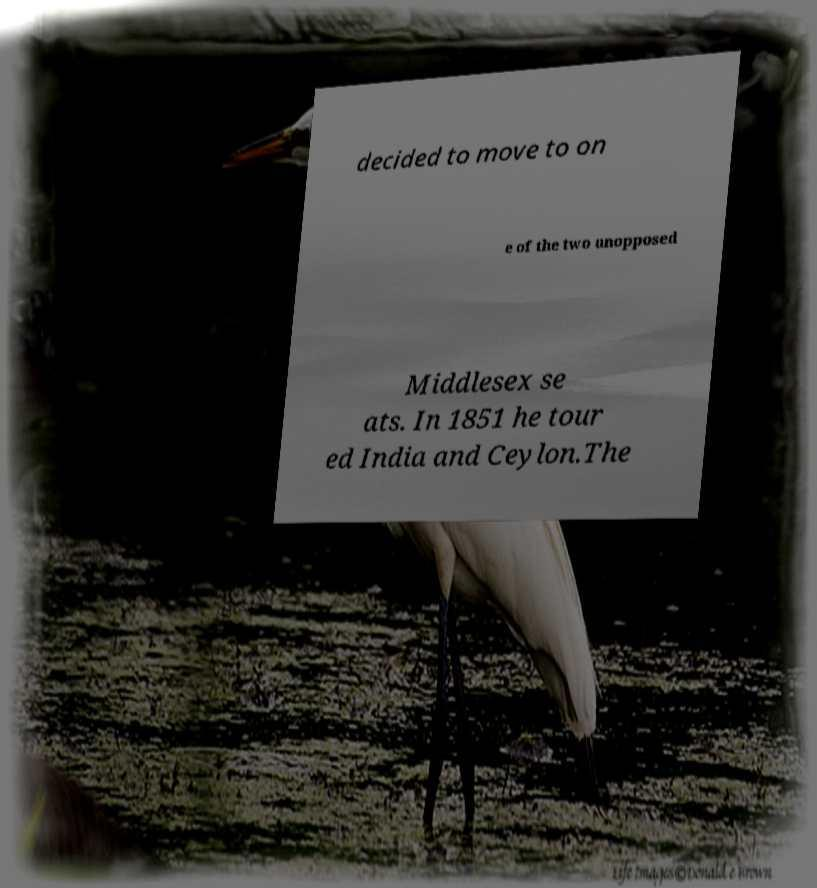What messages or text are displayed in this image? I need them in a readable, typed format. decided to move to on e of the two unopposed Middlesex se ats. In 1851 he tour ed India and Ceylon.The 